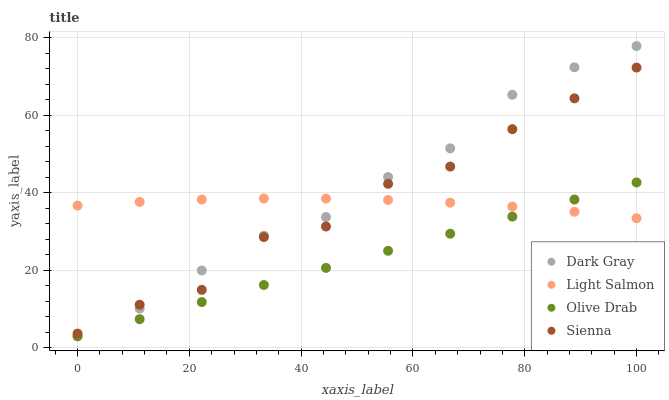Does Olive Drab have the minimum area under the curve?
Answer yes or no. Yes. Does Dark Gray have the maximum area under the curve?
Answer yes or no. Yes. Does Sienna have the minimum area under the curve?
Answer yes or no. No. Does Sienna have the maximum area under the curve?
Answer yes or no. No. Is Olive Drab the smoothest?
Answer yes or no. Yes. Is Sienna the roughest?
Answer yes or no. Yes. Is Light Salmon the smoothest?
Answer yes or no. No. Is Light Salmon the roughest?
Answer yes or no. No. Does Dark Gray have the lowest value?
Answer yes or no. Yes. Does Sienna have the lowest value?
Answer yes or no. No. Does Dark Gray have the highest value?
Answer yes or no. Yes. Does Sienna have the highest value?
Answer yes or no. No. Is Olive Drab less than Sienna?
Answer yes or no. Yes. Is Sienna greater than Olive Drab?
Answer yes or no. Yes. Does Olive Drab intersect Light Salmon?
Answer yes or no. Yes. Is Olive Drab less than Light Salmon?
Answer yes or no. No. Is Olive Drab greater than Light Salmon?
Answer yes or no. No. Does Olive Drab intersect Sienna?
Answer yes or no. No. 